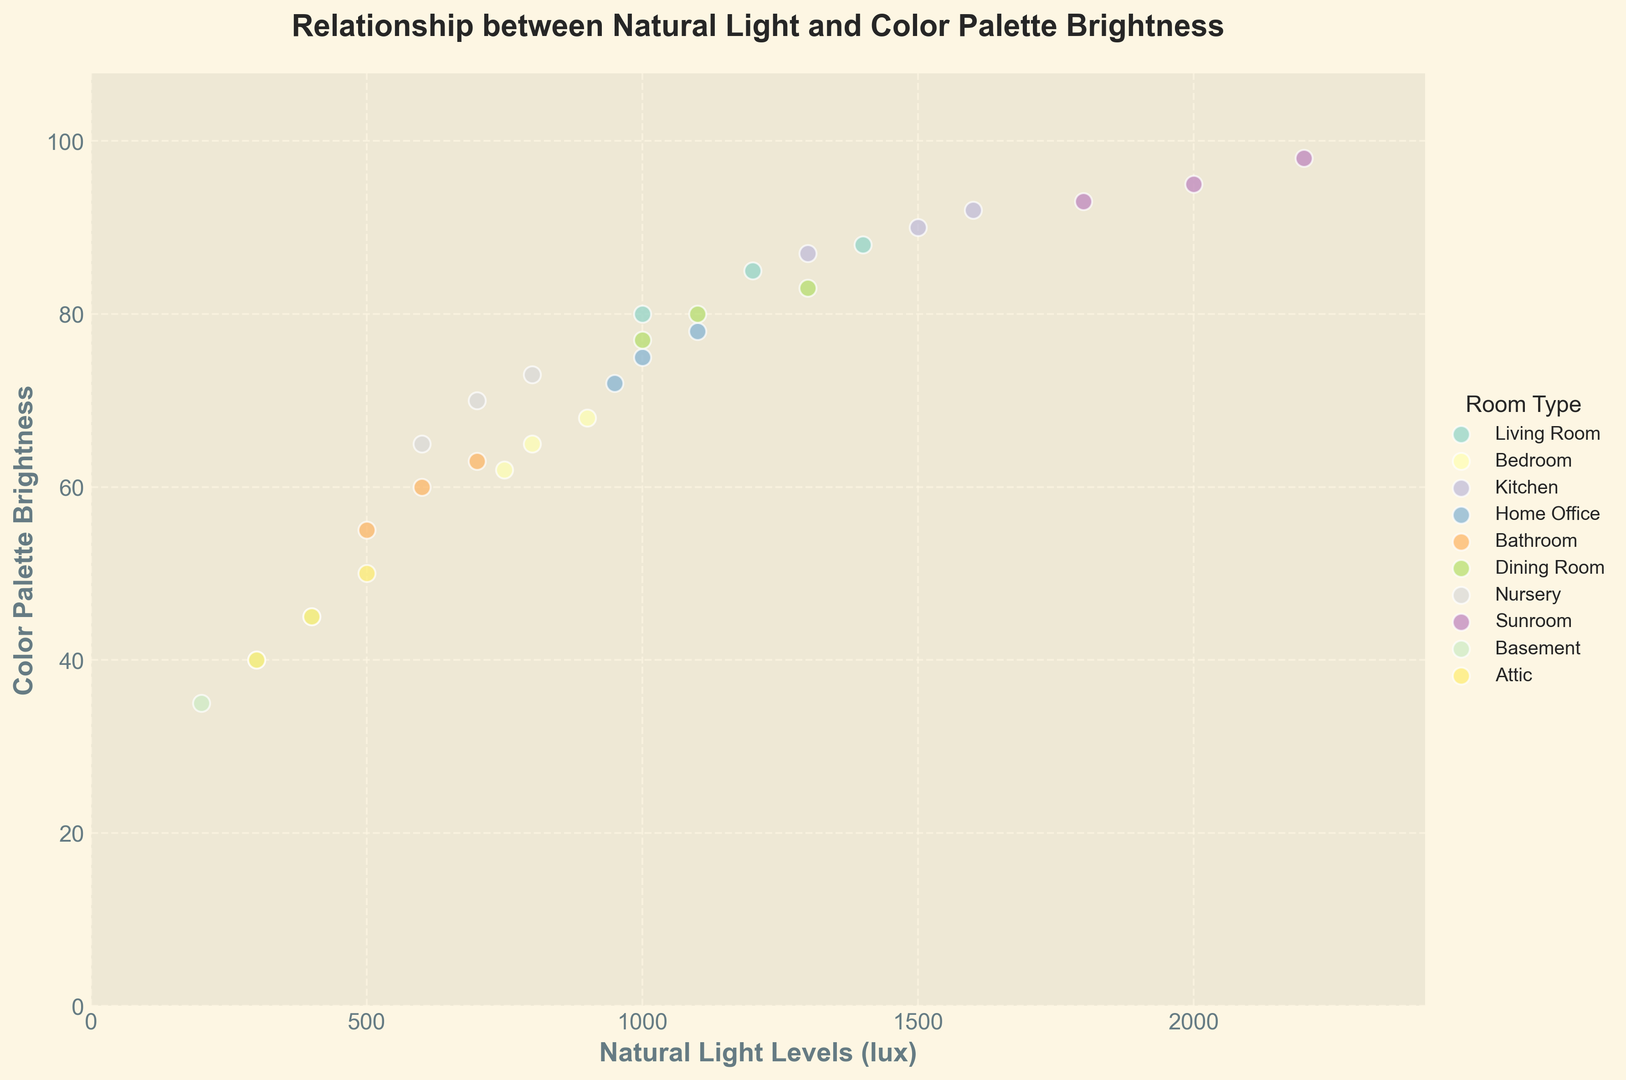What is the range of natural light levels for the sunroom? To determine the range, identify the minimum and maximum natural light levels for the sunroom data points. The minimum natural light is 1800 lux and the maximum is 2200 lux. The range is 2200 - 1800 = 400 lux.
Answer: 400 lux Which room type generally uses the brightest color palette? Examine the scatter plot for the highest color palette brightness values and identify the corresponding room types. The sunroom has the highest brightness values around 95-98.
Answer: Sunroom What is the median natural light level for living rooms? Collect all natural light values for living rooms: 1200, 1400, and 1000 lux. Arrange them in ascending order (1000, 1200, 1400) and identify the middle value, which is 1200 lux.
Answer: 1200 lux Which room type has the greatest variation in natural light levels? Compare the range of natural light levels for each room type by checking the maximum and minimum values on the scatter plot. The sunroom has the widest range from 1800 to 2200 (a range of 400).
Answer: Sunroom Do dining rooms prefer brighter or darker palettes compared to kitchens? Compare the color palette brightness values for dining rooms and kitchens on the scatter plot. Dining rooms have values around 77-83, while kitchens have values around 87-92. Kitchens use brighter palettes.
Answer: Kitchens use brighter palettes What is the average color palette brightness for bedrooms? Identify the color palette brightness values for bedrooms: 65, 68, and 62. Sum these values (65 + 68 + 62 = 195) and divide by the number of data points (3). The average is 195/3 = 65.
Answer: 65 Is there a positive relationship between natural light levels and color palette brightness across all room types? Examine the overall trend in the scatter plot. Higher natural light levels generally correspond to higher color palette brightness values, indicating a positive relationship.
Answer: Yes Comparing bathrooms and home offices, which has a wider range of color palette brightness values? Check the spread of color palette brightness values for both room types. Home offices range from 72 to 78, whereas bathrooms range from 55 to 63. Bathrooms have a wider range (8) compared to home offices (6).
Answer: Bathrooms How many different room types are represented in the scatter plot? Identify all unique room types mentioned in the plot by looking at the legend: Living Room, Bedroom, Kitchen, Home Office, Bathroom, Dining Room, Nursery, Sunroom, Basement, Attic. There are 10 different room types.
Answer: 10 What's the difference in natural light levels between the brightest and darkest basement recordings? Identify the natural light levels for basements on the scatter plot: 300, 200, and 400 lux. The difference between the maximum (400) and minimum (200) is 400 - 200 = 200 lux.
Answer: 200 lux 